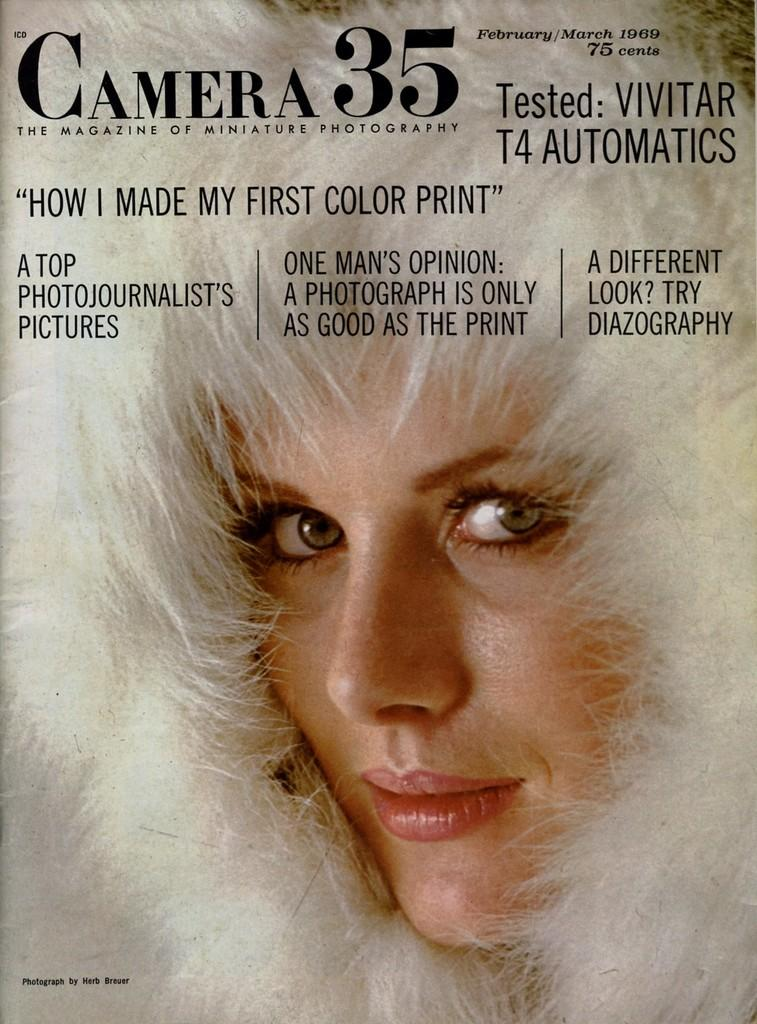What is the main subject of the poster in the image? The poster contains the face of a person. What else can be found on the poster besides the person's face? The poster contains text. What type of nerve is visible in the image? There is no nerve visible in the image; it features a poster with a person's face and text. How many goldfish are swimming in the image? There are no goldfish present in the image. 